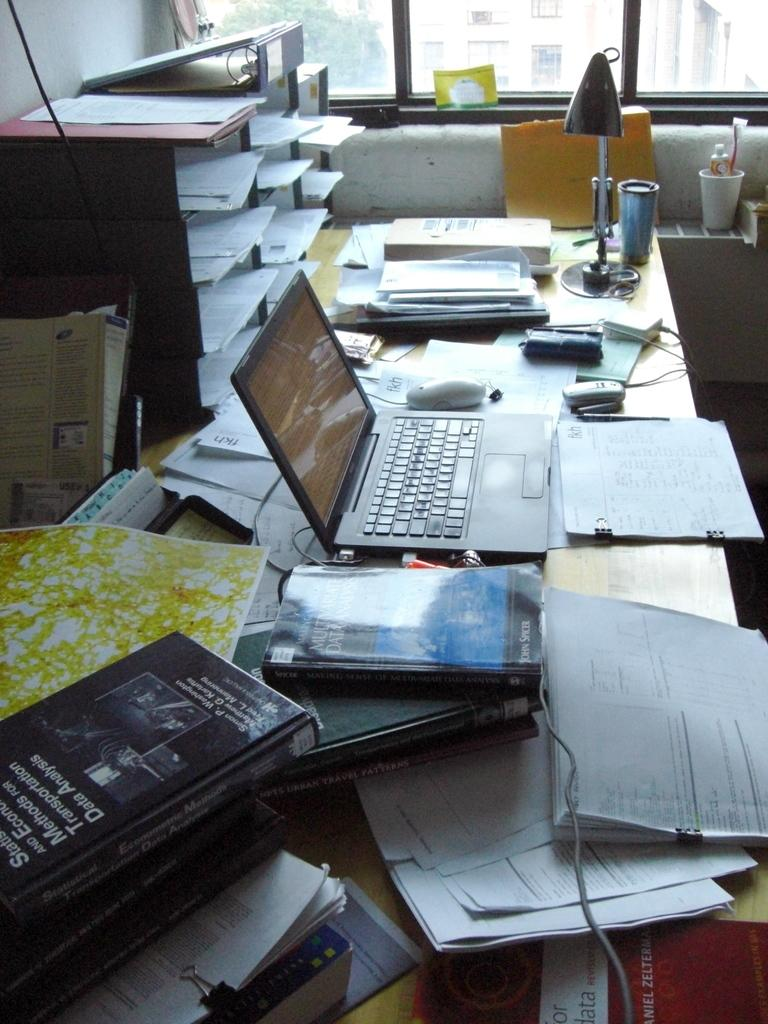What electronic device is on the table in the image? There is a laptop on the table in the image. What else can be seen on the table besides the laptop? There are papers and books on the table. What is the source of light on the table? There is a lamp on the table. What architectural feature is visible on the wall? There is a window on the wall. What type of bucket is hanging on the wall in the image? There is no bucket present in the image. What connection can be made between the laptop and the books in the image? The image does not show any direct connection between the laptop and the books; they are simply separate items on the table. 